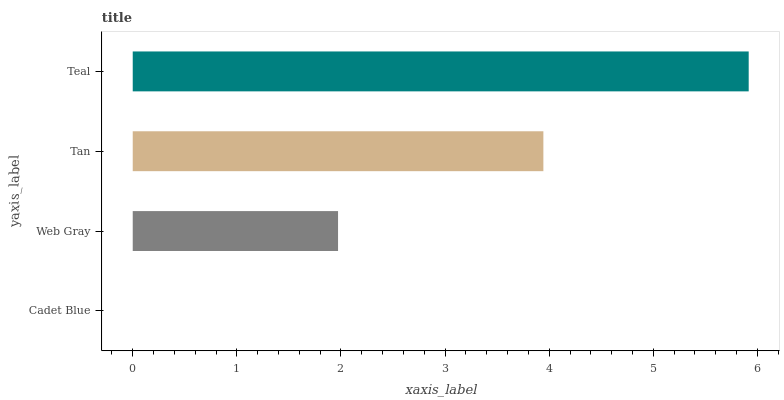Is Cadet Blue the minimum?
Answer yes or no. Yes. Is Teal the maximum?
Answer yes or no. Yes. Is Web Gray the minimum?
Answer yes or no. No. Is Web Gray the maximum?
Answer yes or no. No. Is Web Gray greater than Cadet Blue?
Answer yes or no. Yes. Is Cadet Blue less than Web Gray?
Answer yes or no. Yes. Is Cadet Blue greater than Web Gray?
Answer yes or no. No. Is Web Gray less than Cadet Blue?
Answer yes or no. No. Is Tan the high median?
Answer yes or no. Yes. Is Web Gray the low median?
Answer yes or no. Yes. Is Web Gray the high median?
Answer yes or no. No. Is Cadet Blue the low median?
Answer yes or no. No. 